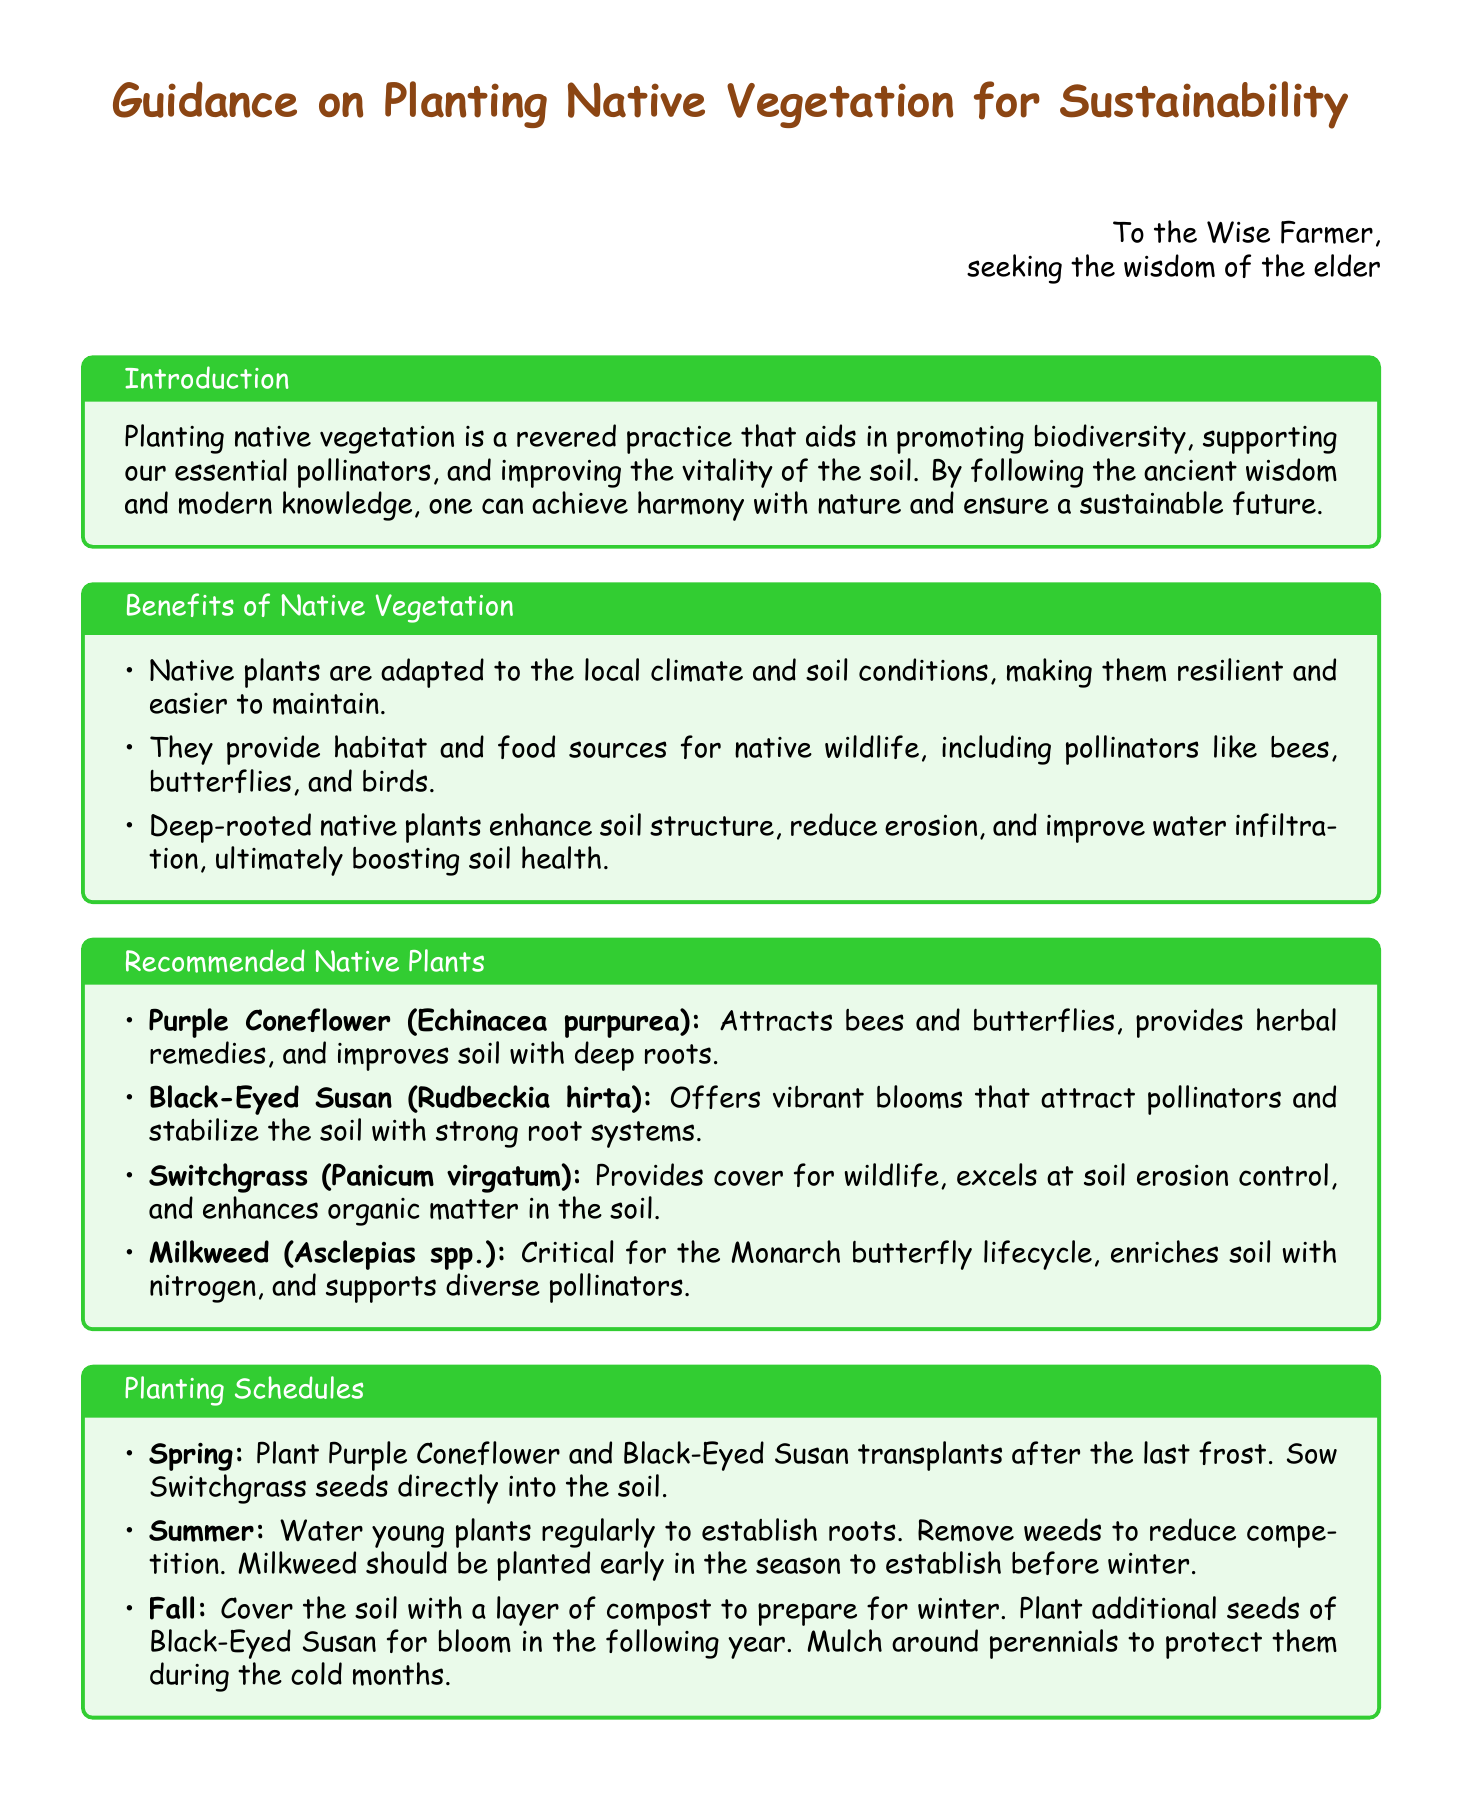What is the primary benefit of planting native vegetation? The document states that planting native vegetation aids in promoting biodiversity, supporting essential pollinators, and improving the vitality of the soil.
Answer: promoting biodiversity, supporting pollinators, and improving soil health Which plant attracts Monarch butterflies? The recommended native plants section mentions that Milkweed is critical for the Monarch butterfly lifecycle.
Answer: Milkweed What season should Purple Coneflower be planted in? The planting schedule clearly specifies to plant Purple Coneflower transplants after the last frost in the spring.
Answer: Spring What type of plant is Switchgrass? The document categorizes Switchgrass as a recommended native plant, noting it as a grass species.
Answer: Grass How should the soil be prepared in the fall? The planting schedules section states to cover the soil with a layer of compost to prepare for winter.
Answer: Cover the soil with compost Which species improves soil with deep roots? The document states that Purple Coneflower improves soil with deep roots among the recommended plants.
Answer: Purple Coneflower What color is used for the section titles? The document mentions that the section titles are colored leaf green.
Answer: Leaf green How often should young plants be watered in summer? The planting schedule advises to water young plants regularly to establish roots during summer.
Answer: Regularly 